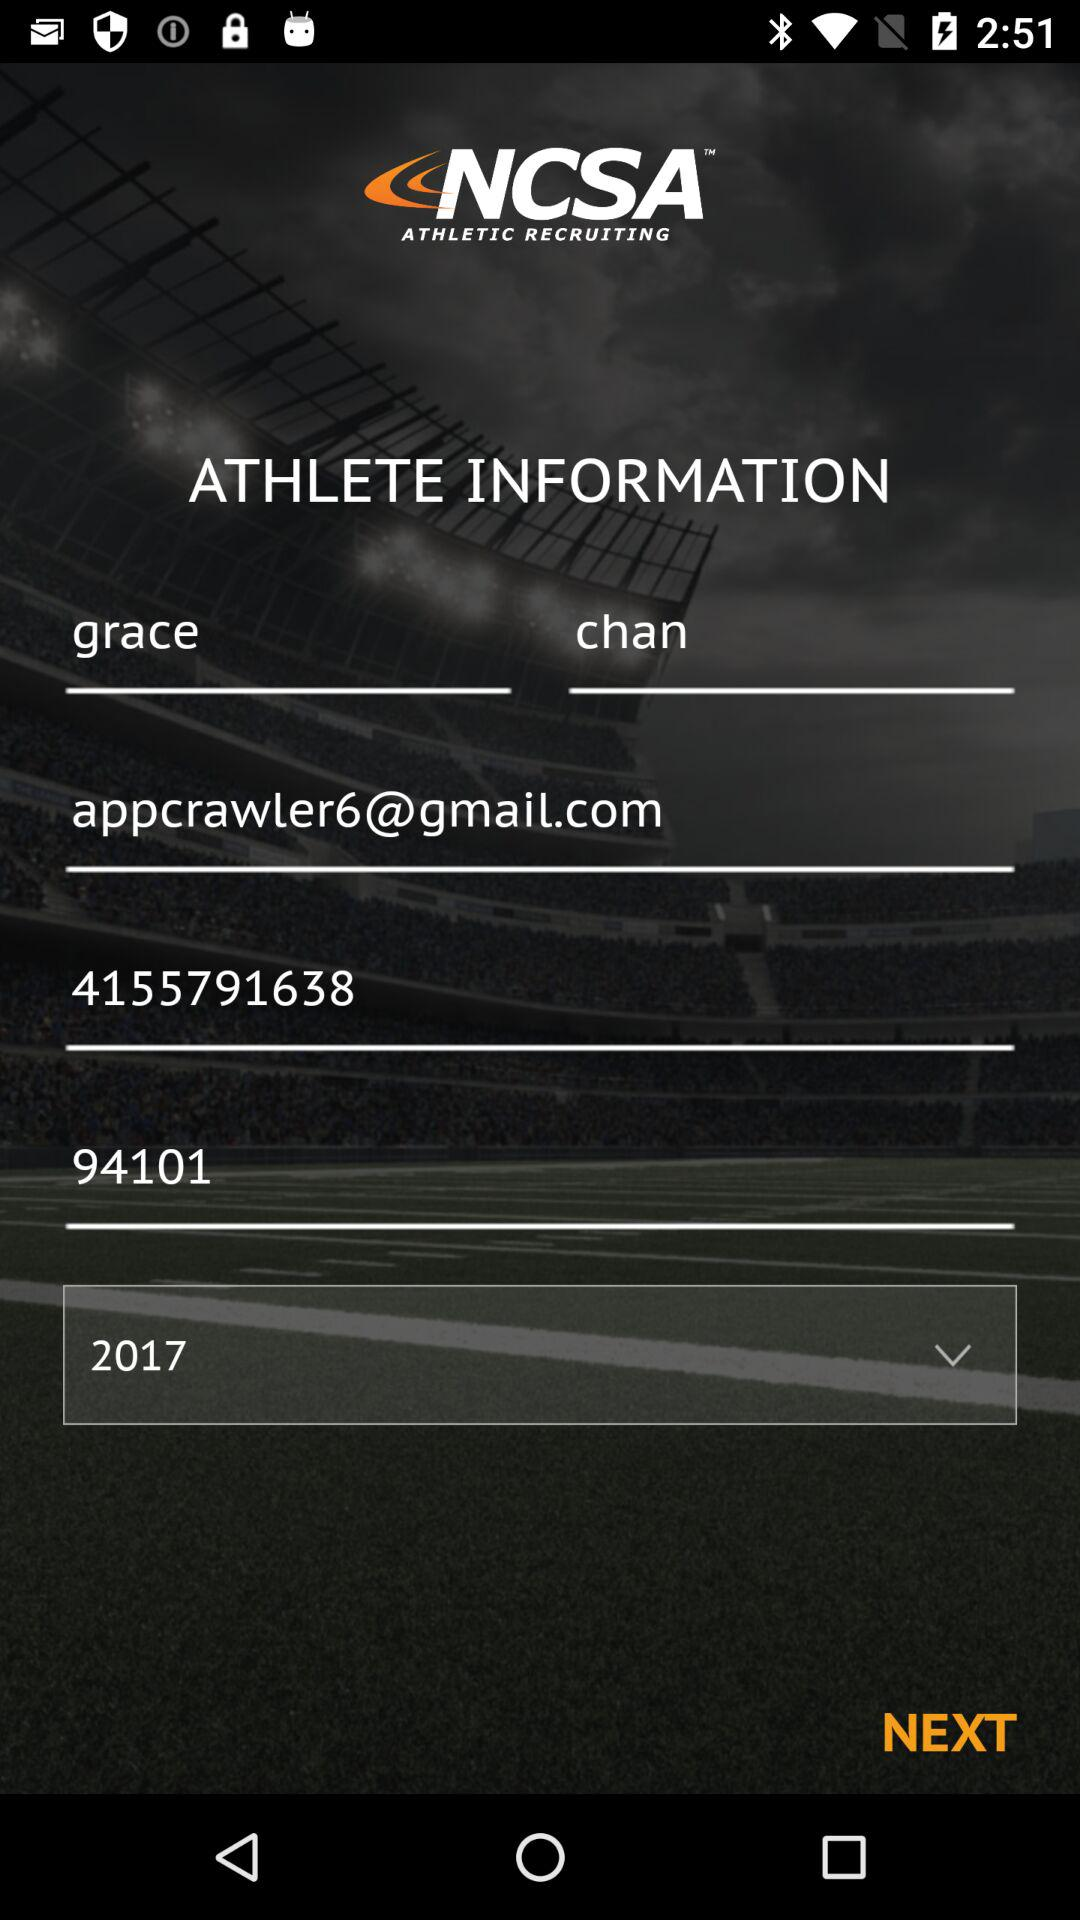What is the user's last name? The user's last name is Chan. 